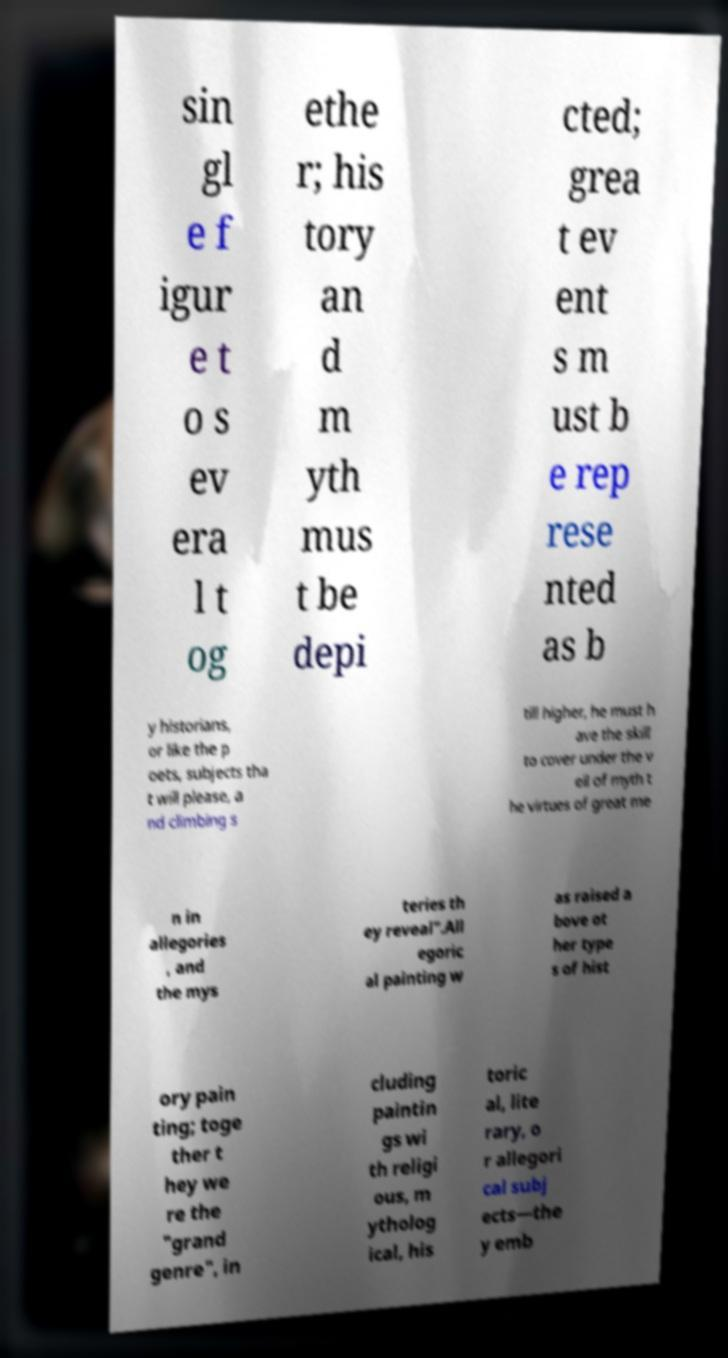Please read and relay the text visible in this image. What does it say? sin gl e f igur e t o s ev era l t og ethe r; his tory an d m yth mus t be depi cted; grea t ev ent s m ust b e rep rese nted as b y historians, or like the p oets, subjects tha t will please, a nd climbing s till higher, he must h ave the skill to cover under the v eil of myth t he virtues of great me n in allegories , and the mys teries th ey reveal".All egoric al painting w as raised a bove ot her type s of hist ory pain ting; toge ther t hey we re the "grand genre", in cluding paintin gs wi th religi ous, m ytholog ical, his toric al, lite rary, o r allegori cal subj ects—the y emb 